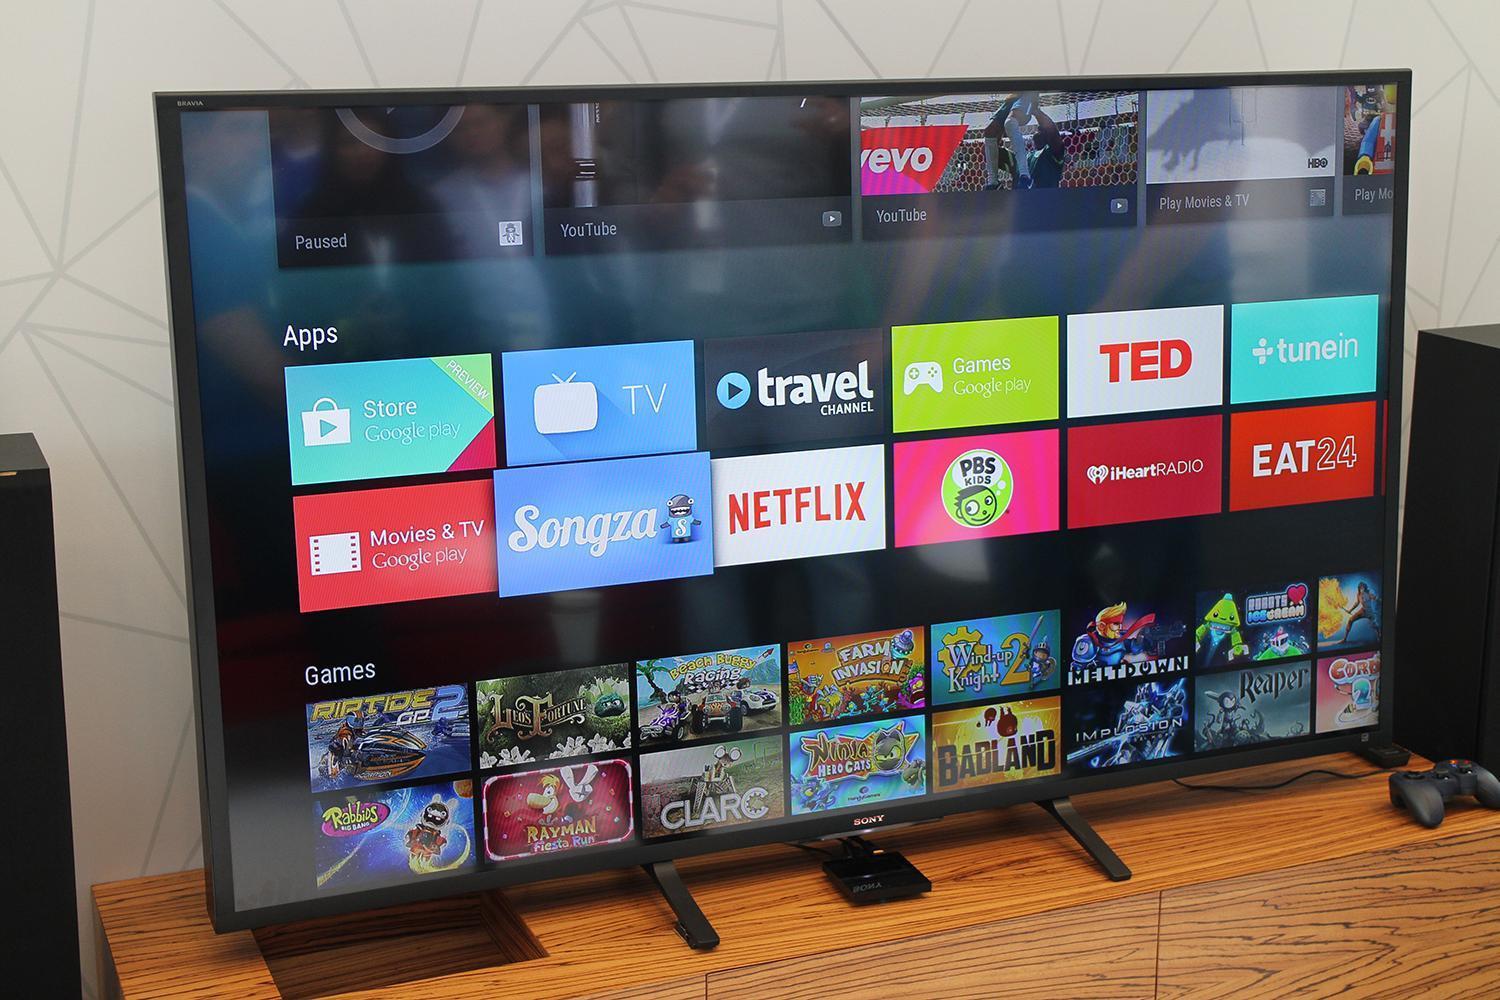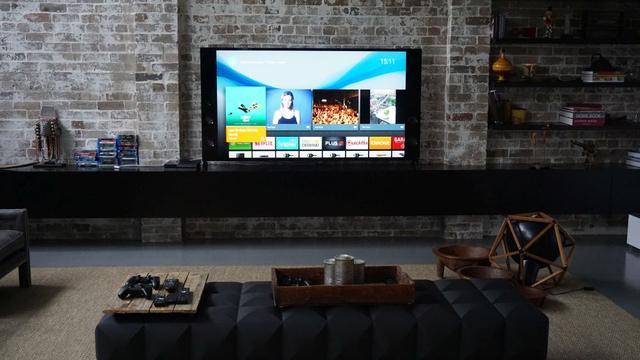The first image is the image on the left, the second image is the image on the right. Examine the images to the left and right. Is the description "One of the televisions is in front of a bricked wall." accurate? Answer yes or no. Yes. The first image is the image on the left, the second image is the image on the right. Assess this claim about the two images: "The right image contains more screened devices than the left image.". Correct or not? Answer yes or no. No. 